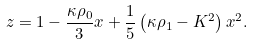<formula> <loc_0><loc_0><loc_500><loc_500>z = 1 - \frac { \kappa \rho _ { 0 } } 3 x + \frac { 1 } { 5 } \left ( \kappa \rho _ { 1 } - K ^ { 2 } \right ) x ^ { 2 } .</formula> 